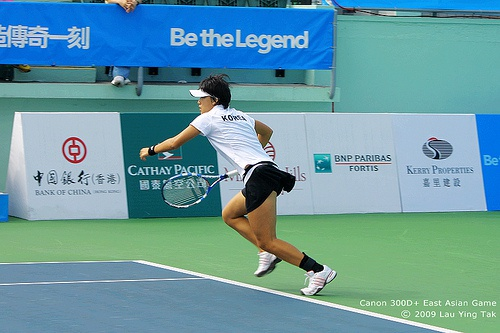Describe the objects in this image and their specific colors. I can see people in violet, black, lavender, brown, and maroon tones, tennis racket in violet, teal, and darkgray tones, and people in violet, black, navy, and olive tones in this image. 